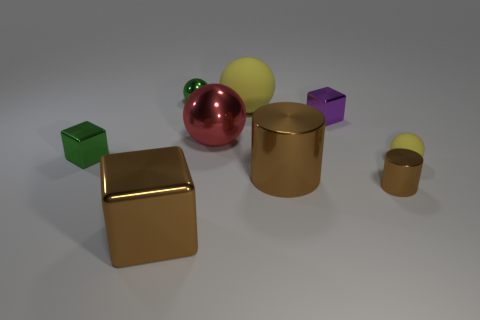Which objects in the image are spheres? In the image, the red and yellow objects toward the back are spheres. 